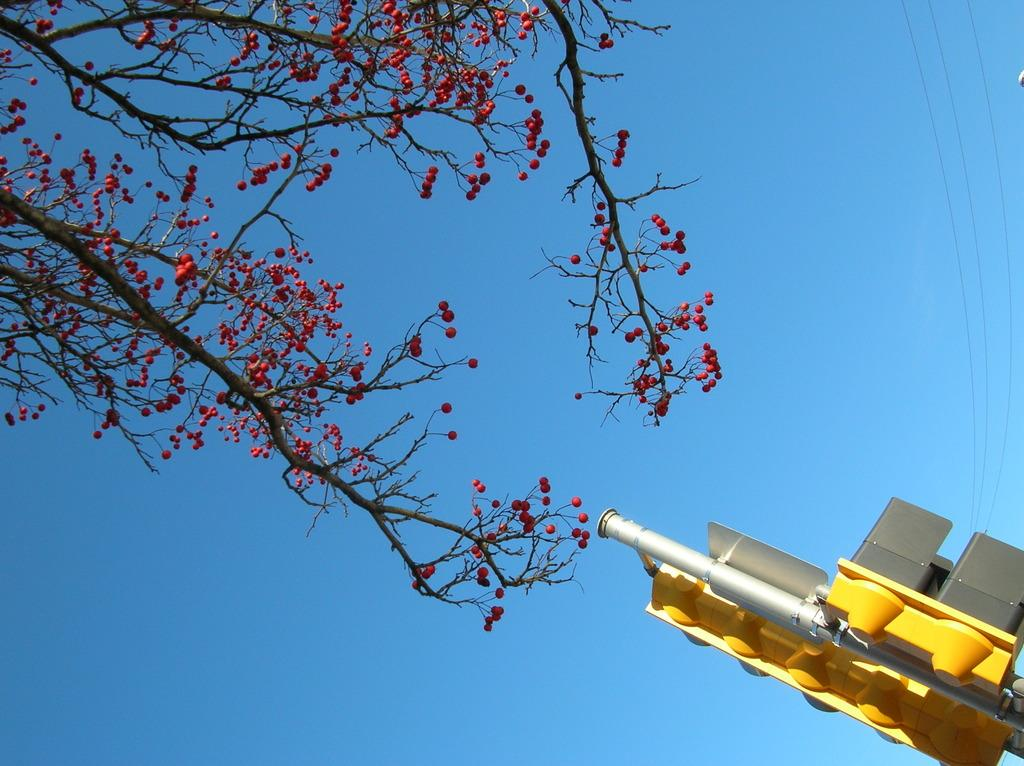What type of flower tree is present in the image? There is a red color flower tree in the image. What other object can be seen in the image besides the flower tree? There is a yellow color traffic pole in the image. What color is the sky in the image? The sky is blue in the image. Can you see any beetles crawling on the flower tree in the image? There is no mention of beetles in the image, so we cannot determine if any are present. 